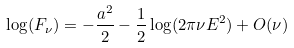Convert formula to latex. <formula><loc_0><loc_0><loc_500><loc_500>\log ( F _ { \nu } ) = - \frac { a ^ { 2 } } { 2 } - \frac { 1 } { 2 } \log ( 2 \pi \nu E ^ { 2 } ) + O ( \nu )</formula> 